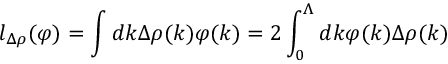<formula> <loc_0><loc_0><loc_500><loc_500>l _ { \Delta \rho } ( \varphi ) = \int d k \Delta \rho ( k ) \varphi ( k ) = 2 \int _ { 0 } ^ { \Lambda } d k \varphi ( k ) \Delta \rho ( k )</formula> 